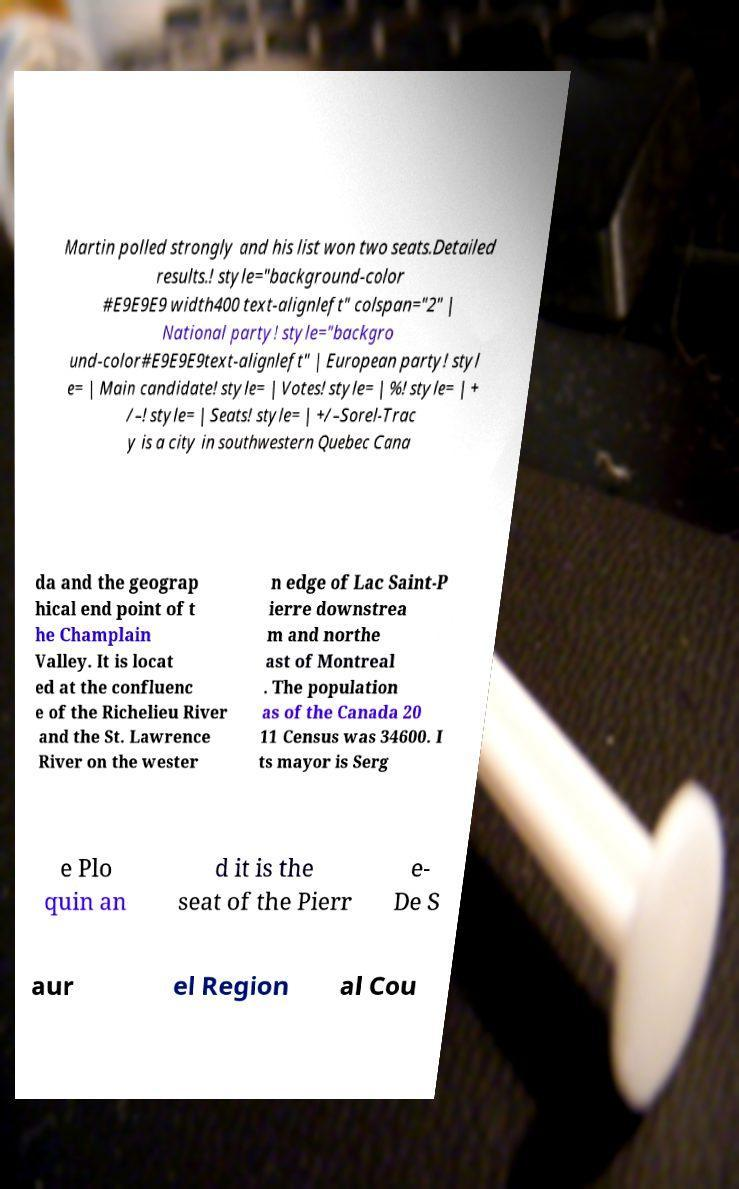Please read and relay the text visible in this image. What does it say? Martin polled strongly and his list won two seats.Detailed results.! style="background-color #E9E9E9 width400 text-alignleft" colspan="2" | National party! style="backgro und-color#E9E9E9text-alignleft" | European party! styl e= | Main candidate! style= | Votes! style= | %! style= | + /–! style= | Seats! style= | +/–Sorel-Trac y is a city in southwestern Quebec Cana da and the geograp hical end point of t he Champlain Valley. It is locat ed at the confluenc e of the Richelieu River and the St. Lawrence River on the wester n edge of Lac Saint-P ierre downstrea m and northe ast of Montreal . The population as of the Canada 20 11 Census was 34600. I ts mayor is Serg e Plo quin an d it is the seat of the Pierr e- De S aur el Region al Cou 